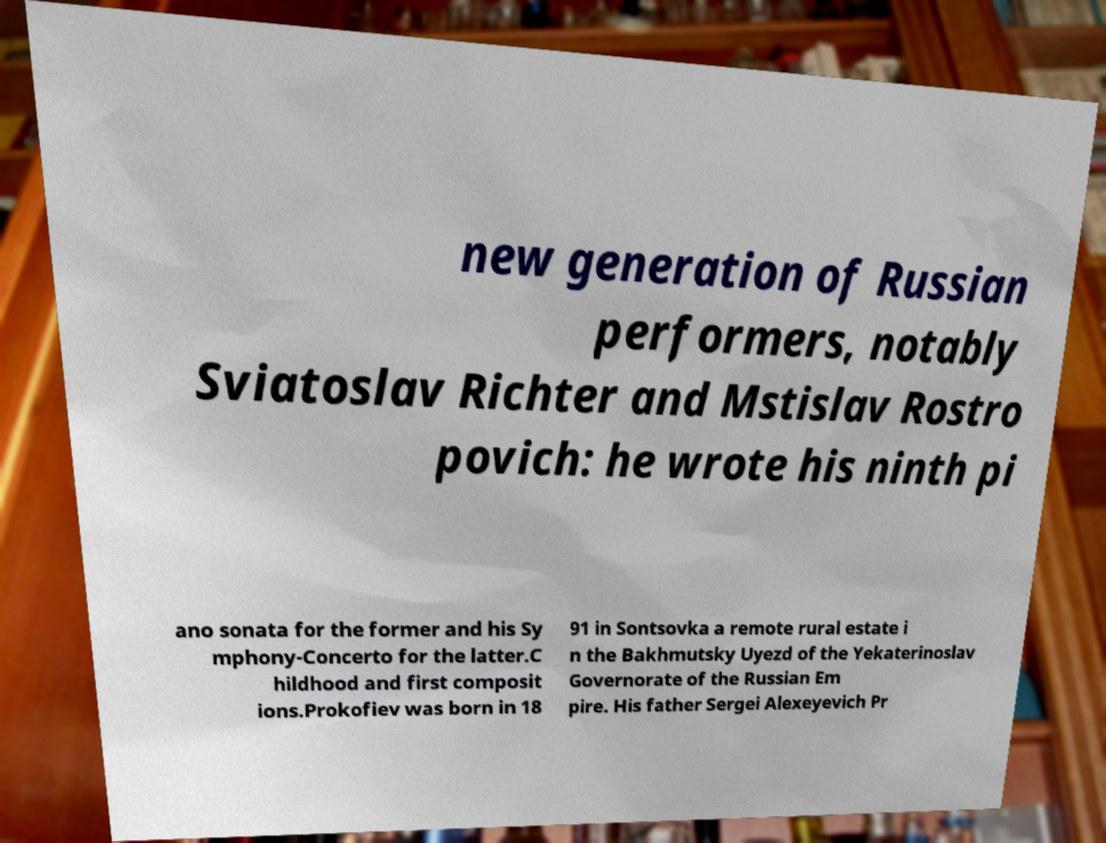For documentation purposes, I need the text within this image transcribed. Could you provide that? new generation of Russian performers, notably Sviatoslav Richter and Mstislav Rostro povich: he wrote his ninth pi ano sonata for the former and his Sy mphony-Concerto for the latter.C hildhood and first composit ions.Prokofiev was born in 18 91 in Sontsovka a remote rural estate i n the Bakhmutsky Uyezd of the Yekaterinoslav Governorate of the Russian Em pire. His father Sergei Alexeyevich Pr 